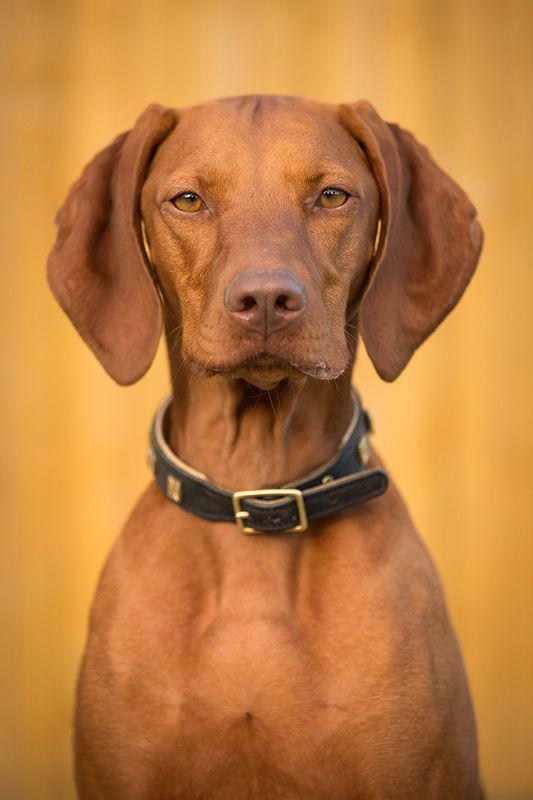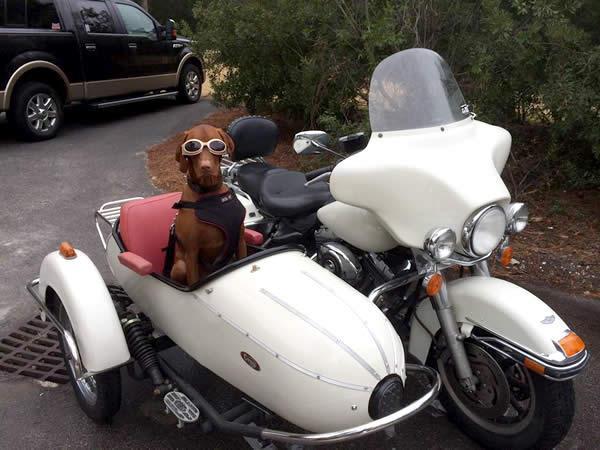The first image is the image on the left, the second image is the image on the right. Examine the images to the left and right. Is the description "The white motorbike has a dog passenger but no driver." accurate? Answer yes or no. Yes. 